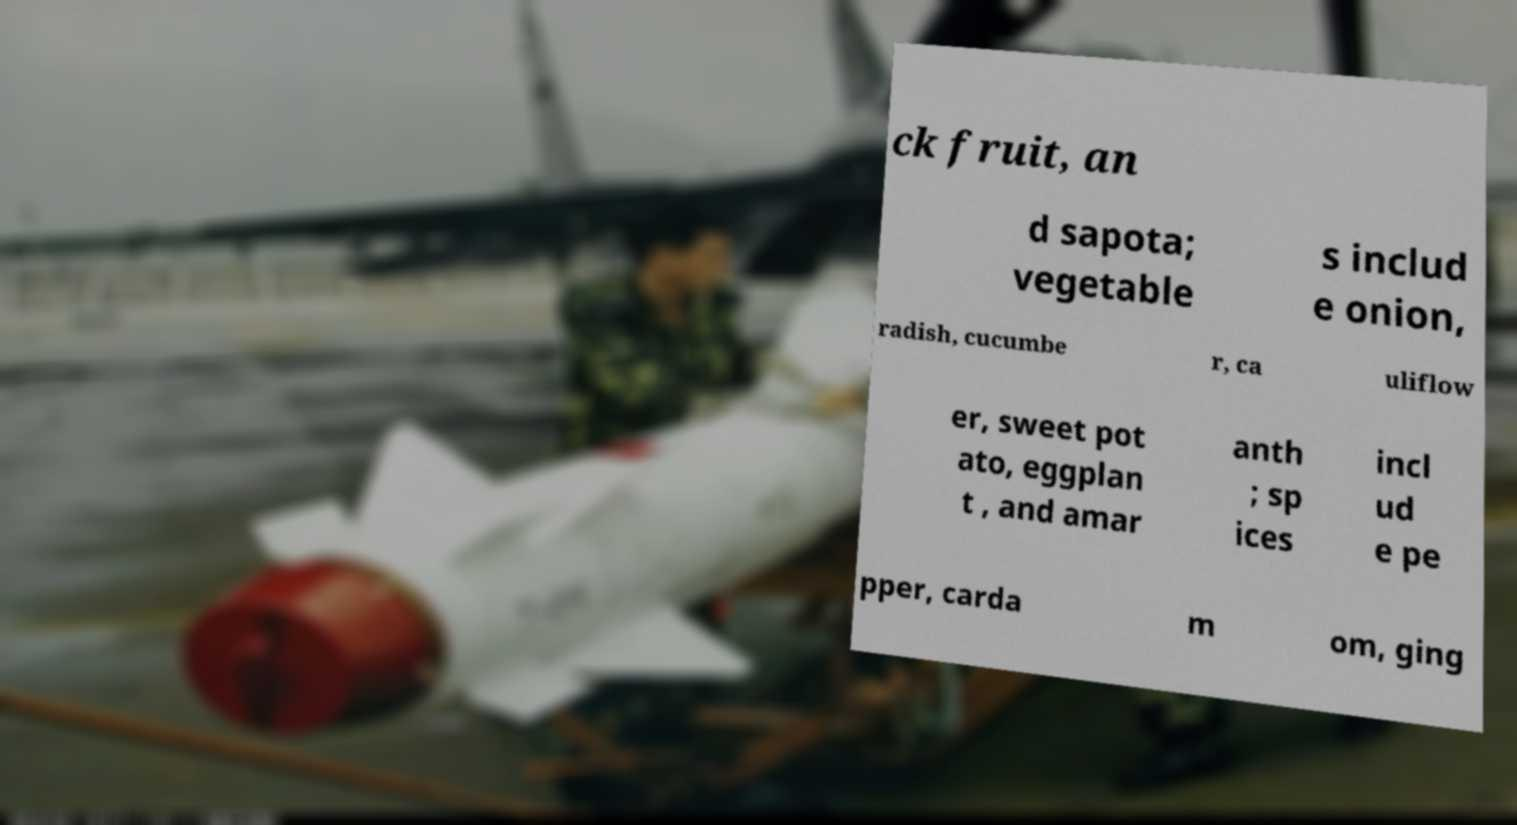Can you accurately transcribe the text from the provided image for me? ck fruit, an d sapota; vegetable s includ e onion, radish, cucumbe r, ca uliflow er, sweet pot ato, eggplan t , and amar anth ; sp ices incl ud e pe pper, carda m om, ging 